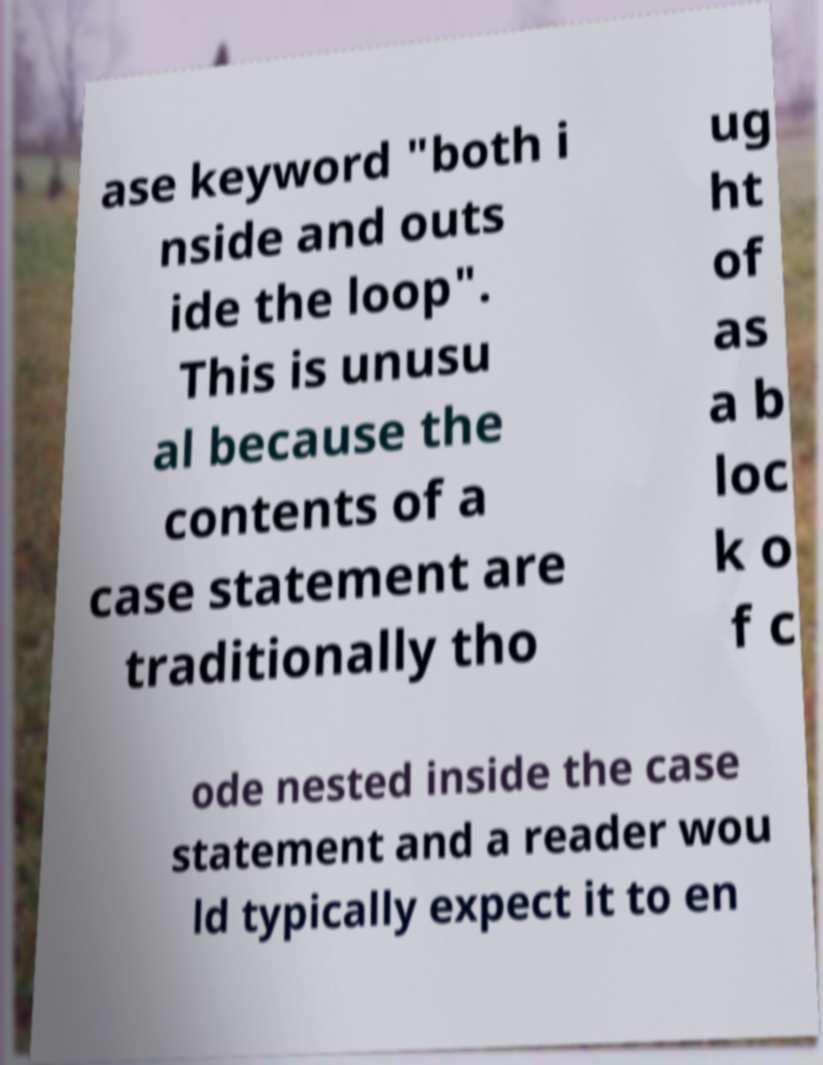What messages or text are displayed in this image? I need them in a readable, typed format. ase keyword "both i nside and outs ide the loop". This is unusu al because the contents of a case statement are traditionally tho ug ht of as a b loc k o f c ode nested inside the case statement and a reader wou ld typically expect it to en 